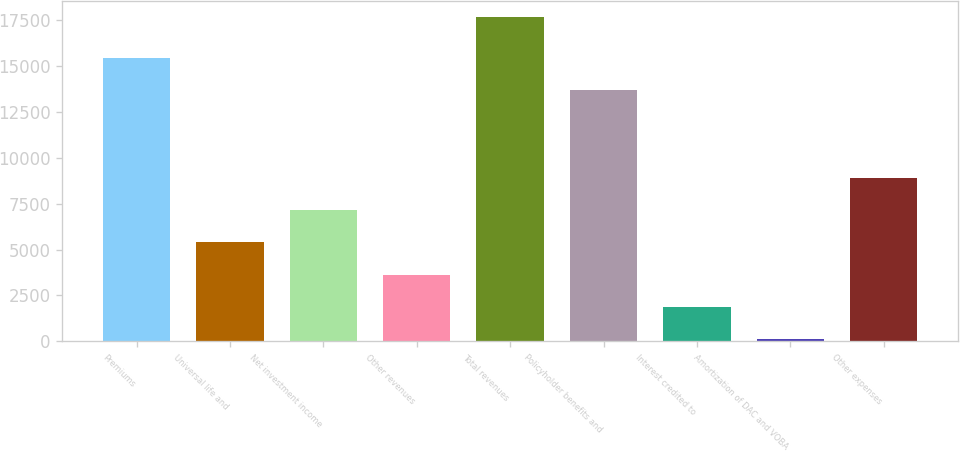Convert chart. <chart><loc_0><loc_0><loc_500><loc_500><bar_chart><fcel>Premiums<fcel>Universal life and<fcel>Net investment income<fcel>Other revenues<fcel>Total revenues<fcel>Policyholder benefits and<fcel>Interest credited to<fcel>Amortization of DAC and VOBA<fcel>Other expenses<nl><fcel>15442.3<fcel>5386.9<fcel>7138.2<fcel>3635.6<fcel>17646<fcel>13691<fcel>1884.3<fcel>133<fcel>8889.5<nl></chart> 